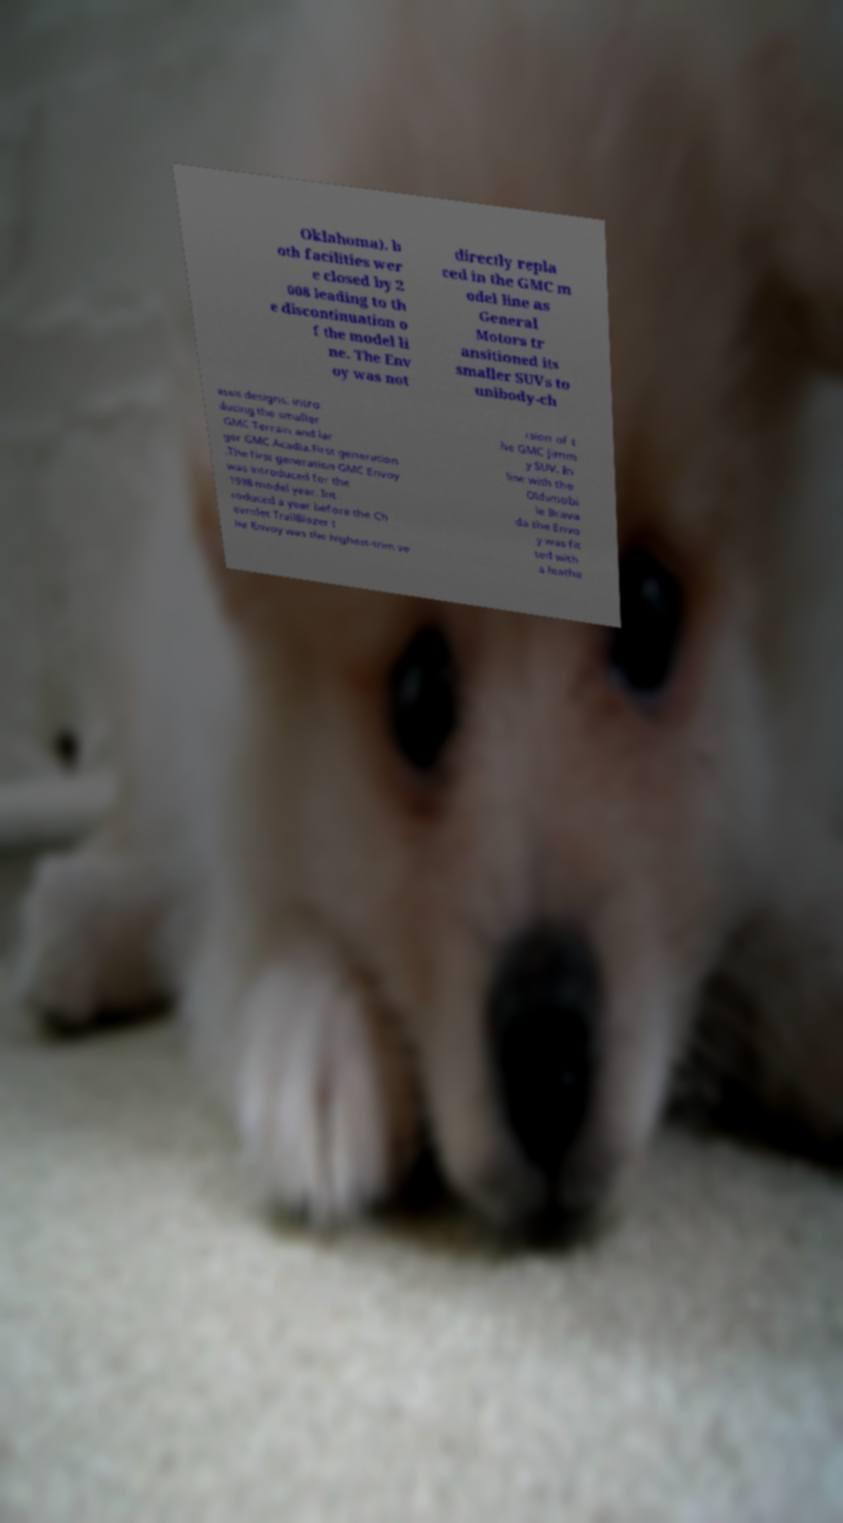Can you accurately transcribe the text from the provided image for me? Oklahoma). b oth facilities wer e closed by 2 008 leading to th e discontinuation o f the model li ne. The Env oy was not directly repla ced in the GMC m odel line as General Motors tr ansitioned its smaller SUVs to unibody-ch assis designs. intro ducing the smaller GMC Terrain and lar ger GMC Acadia.First generation .The first generation GMC Envoy was introduced for the 1998 model year. Int roduced a year before the Ch evrolet TrailBlazer t he Envoy was the highest-trim ve rsion of t he GMC Jimm y SUV. In line with the Oldsmobi le Brava da the Envo y was fit ted with a leathe 